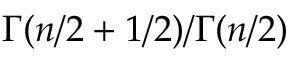<formula> <loc_0><loc_0><loc_500><loc_500>\Gamma ( n / 2 + 1 / 2 ) / \Gamma ( n / 2 )</formula> 